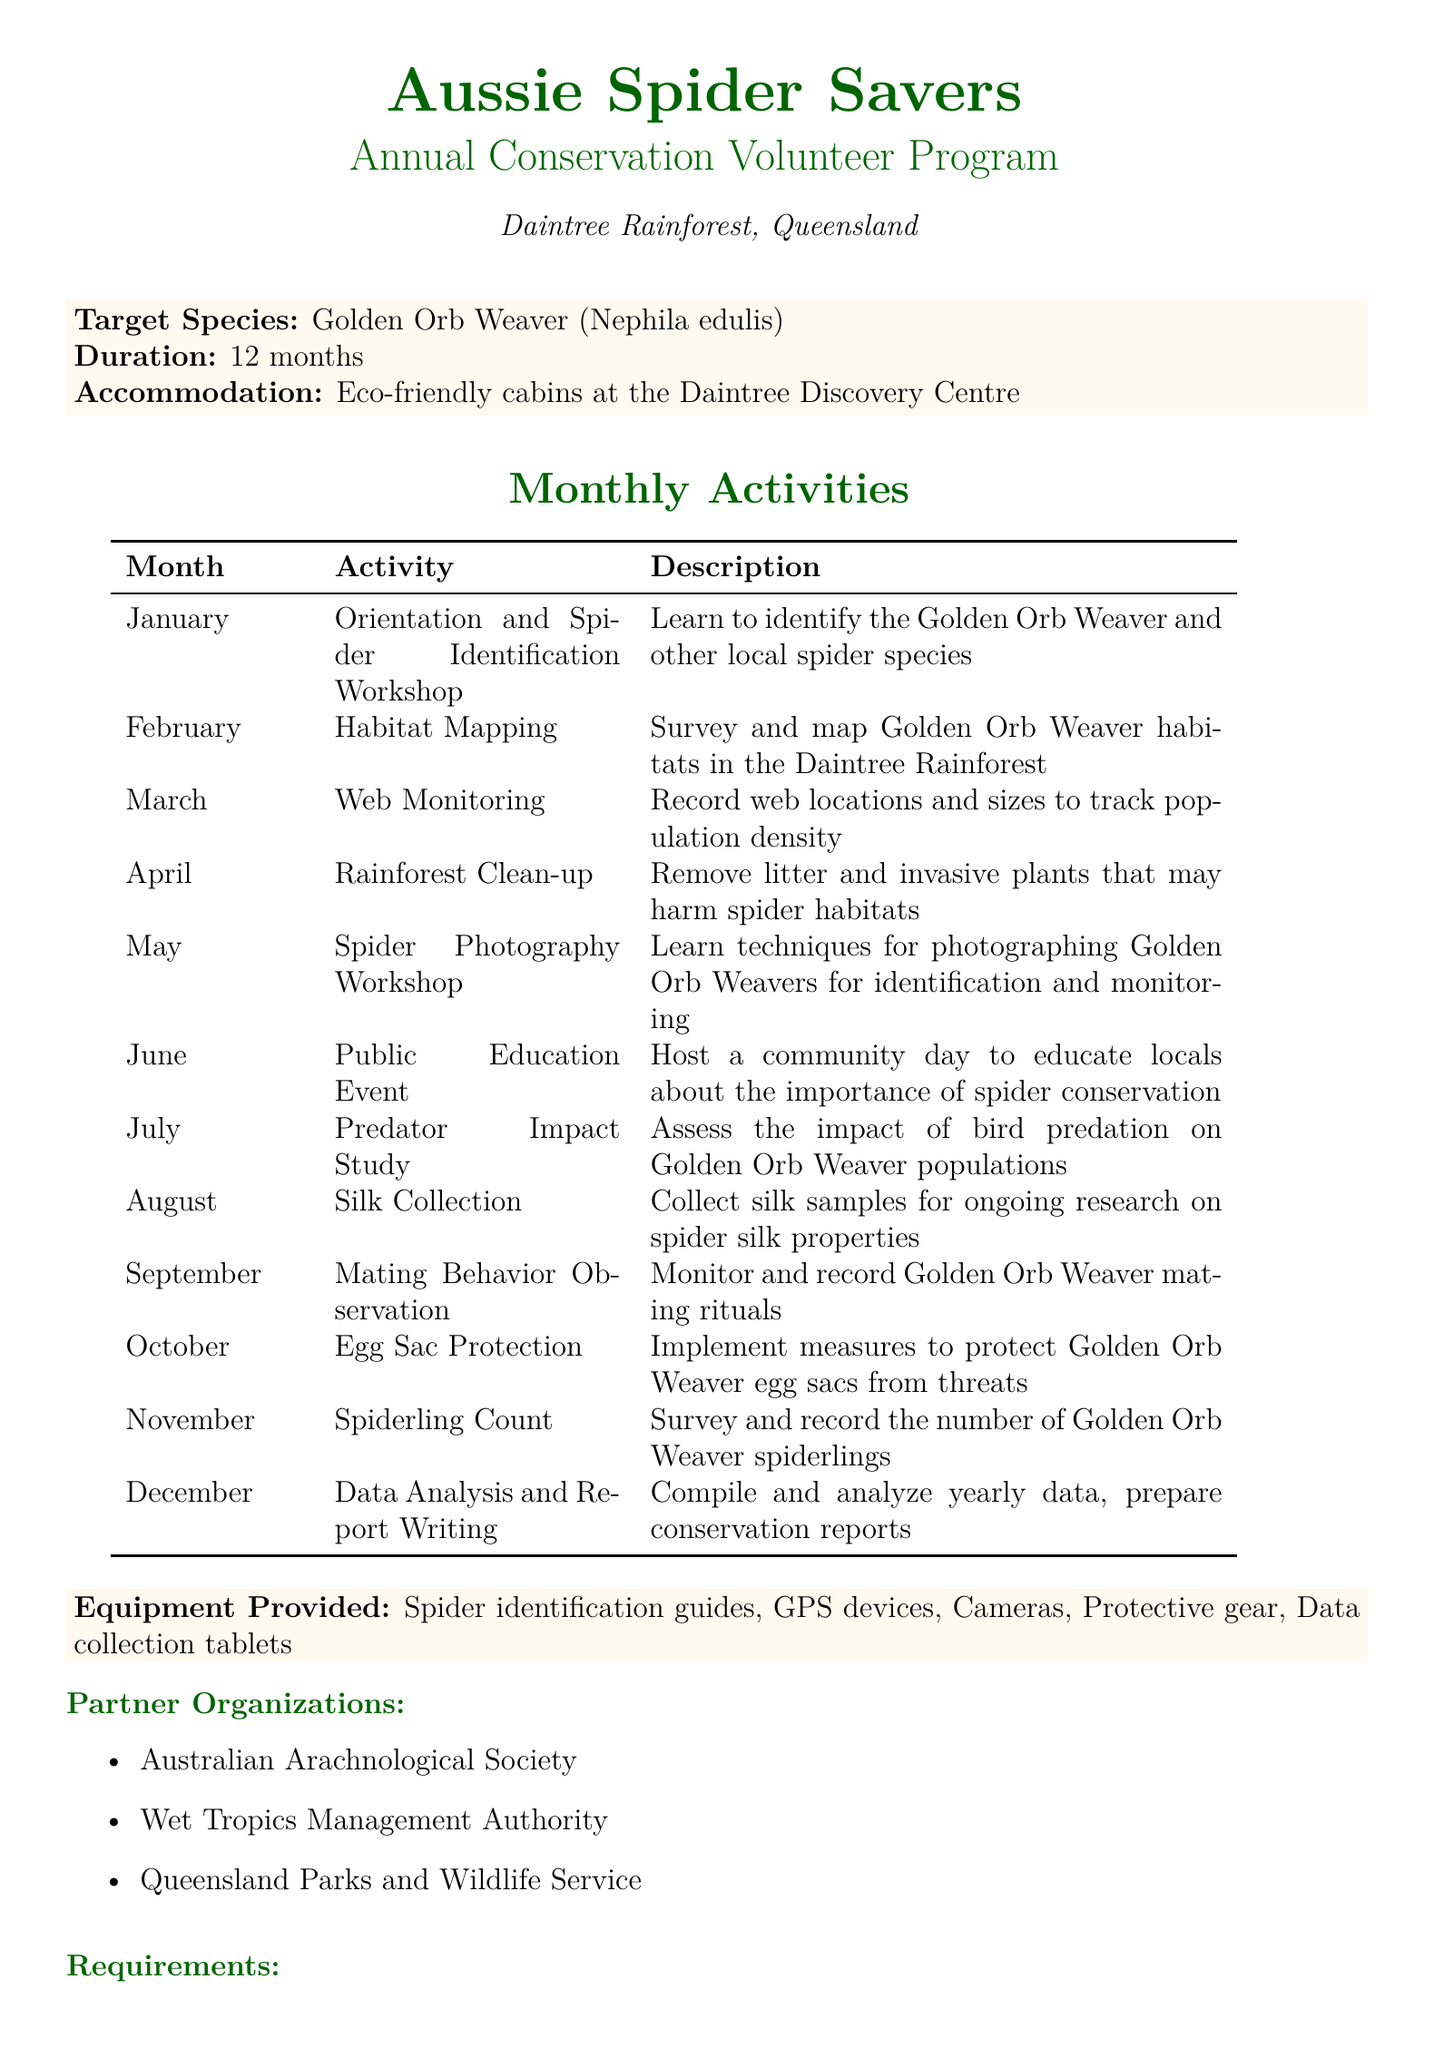What is the target species of the program? The target species is specifically mentioned in the document under the header for target species.
Answer: Golden Orb Weaver (Nephila edulis) What is the duration of the program? The duration is specified near the top of the document under program details.
Answer: 12 months In which location is the program held? The location information is provided right after the program name.
Answer: Daintree Rainforest, Queensland What activity takes place in June? The activities for each month are clearly listed in the monthly activities section of the document.
Answer: Public Education Event Which organization is a partner in this program? Partner organizations are listed in a separate section; one of them is mentioned directly.
Answer: Australian Arachnological Society What type of accommodation is provided? The accommodation details are mentioned along with other program specifics.
Answer: Eco-friendly cabins at the Daintree Discovery Centre What is required of participants regarding fitness? Requirements for participation include different aspects, including fitness levels.
Answer: Basic fitness level How many monthly activities are listed in the document? The number of activities can be determined by counting the entries under monthly activities.
Answer: 12 What type of workshop is held in May? May's activity is mentioned in the monthly activities section.
Answer: Spider Photography Workshop What is one educational component mentioned? Educational components are listed towards the end of the document, identifying the types of learning opportunities provided.
Answer: Weekly lectures on Australian spider ecology 